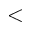Convert formula to latex. <formula><loc_0><loc_0><loc_500><loc_500><</formula> 